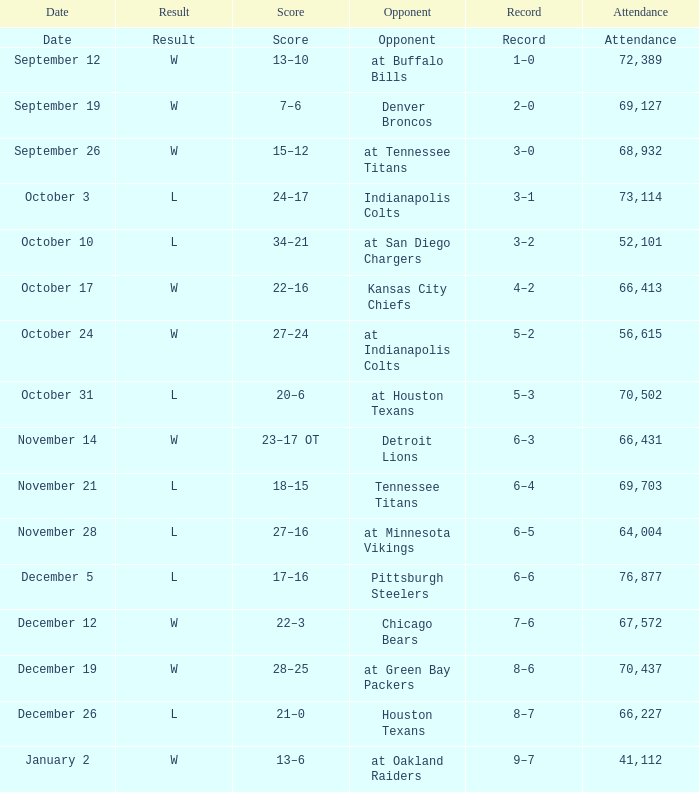What score has October 31 as the date? 20–6. 